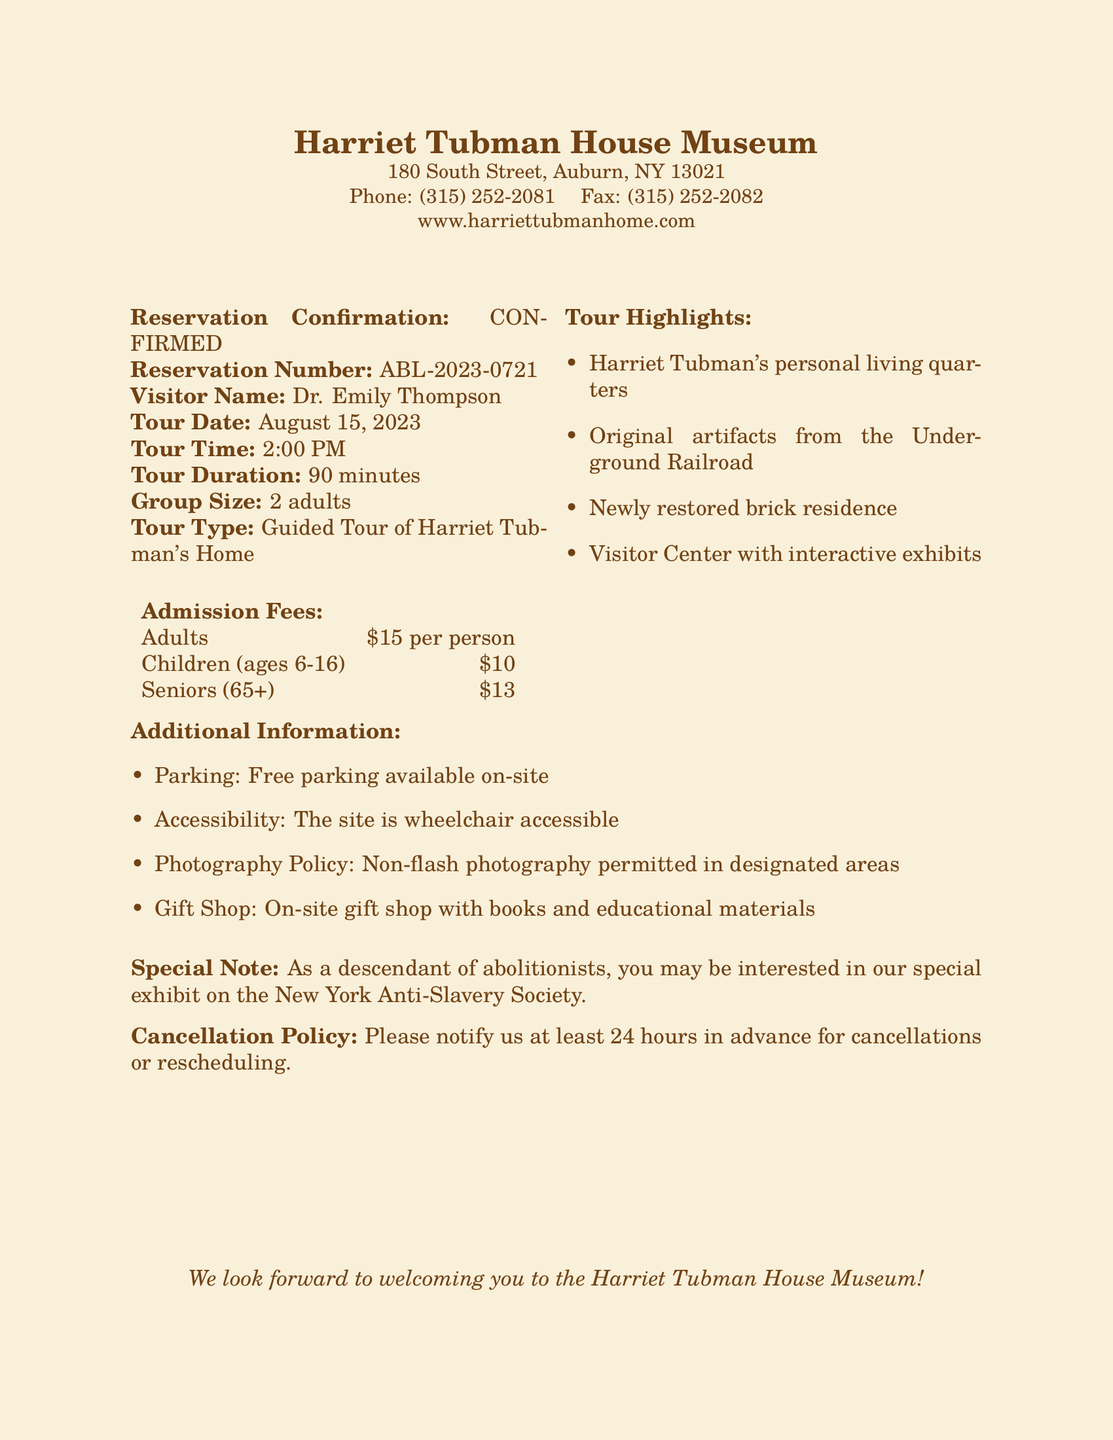What is the reservation number? The reservation number is provided under "Reservation Number" in the document as a unique identifier for the booking.
Answer: ABL-2023-0721 What is the tour duration? The tour duration is specified in the document, indicating how long the guided tour will last.
Answer: 90 minutes Who is the visitor? The visitor's name is explicitly mentioned in the document as part of the reservation confirmation details.
Answer: Dr. Emily Thompson What highlights are included in the tour? The document lists several highlights, indicating what visitors can expect to see during the tour.
Answer: Harriet Tubman's personal living quarters How much is the admission fee for seniors? The admission fee for seniors is provided in the admission fees section, outlining the cost for this group category.
Answer: $13 What is the cancellation policy? The cancellation policy informs visitors about the requirements for cancelling or rescheduling their reservations.
Answer: Notify at least 24 hours in advance Is the site wheelchair accessible? The document mentions accessibility features, providing information on whether the site accommodates visitors with mobility challenges.
Answer: Yes What special exhibit is mentioned? The document highlights a specific exhibit that might interest descendants of abolitionists, demonstrating the museum's focus.
Answer: New York Anti-Slavery Society 